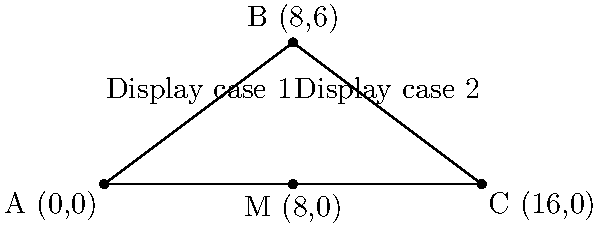In your bakery showroom, you want to optimize the arrangement of two display cases. The first case extends from point A(0,0) to B(8,6), and the second from B(8,6) to C(16,0). To ensure a balanced layout, you decide to place a decorative element at the midpoint of AC. Calculate the slope of line AB and determine the coordinates of the midpoint M of line AC. To solve this problem, we'll follow these steps:

1. Calculate the slope of line AB:
   The slope formula is $m = \frac{y_2 - y_1}{x_2 - x_1}$
   For AB: $m_{AB} = \frac{6 - 0}{8 - 0} = \frac{6}{8} = \frac{3}{4}$

2. Find the midpoint M of line AC:
   The midpoint formula is $M(\frac{x_1 + x_2}{2}, \frac{y_1 + y_2}{2})$
   For AC: $M(\frac{0 + 16}{2}, \frac{0 + 0}{2}) = (8, 0)$

Therefore, the slope of line AB (display case 1) is $\frac{3}{4}$, and the coordinates of the midpoint M (where the decorative element should be placed) are (8, 0).
Answer: Slope of AB: $\frac{3}{4}$; Midpoint M: (8, 0) 